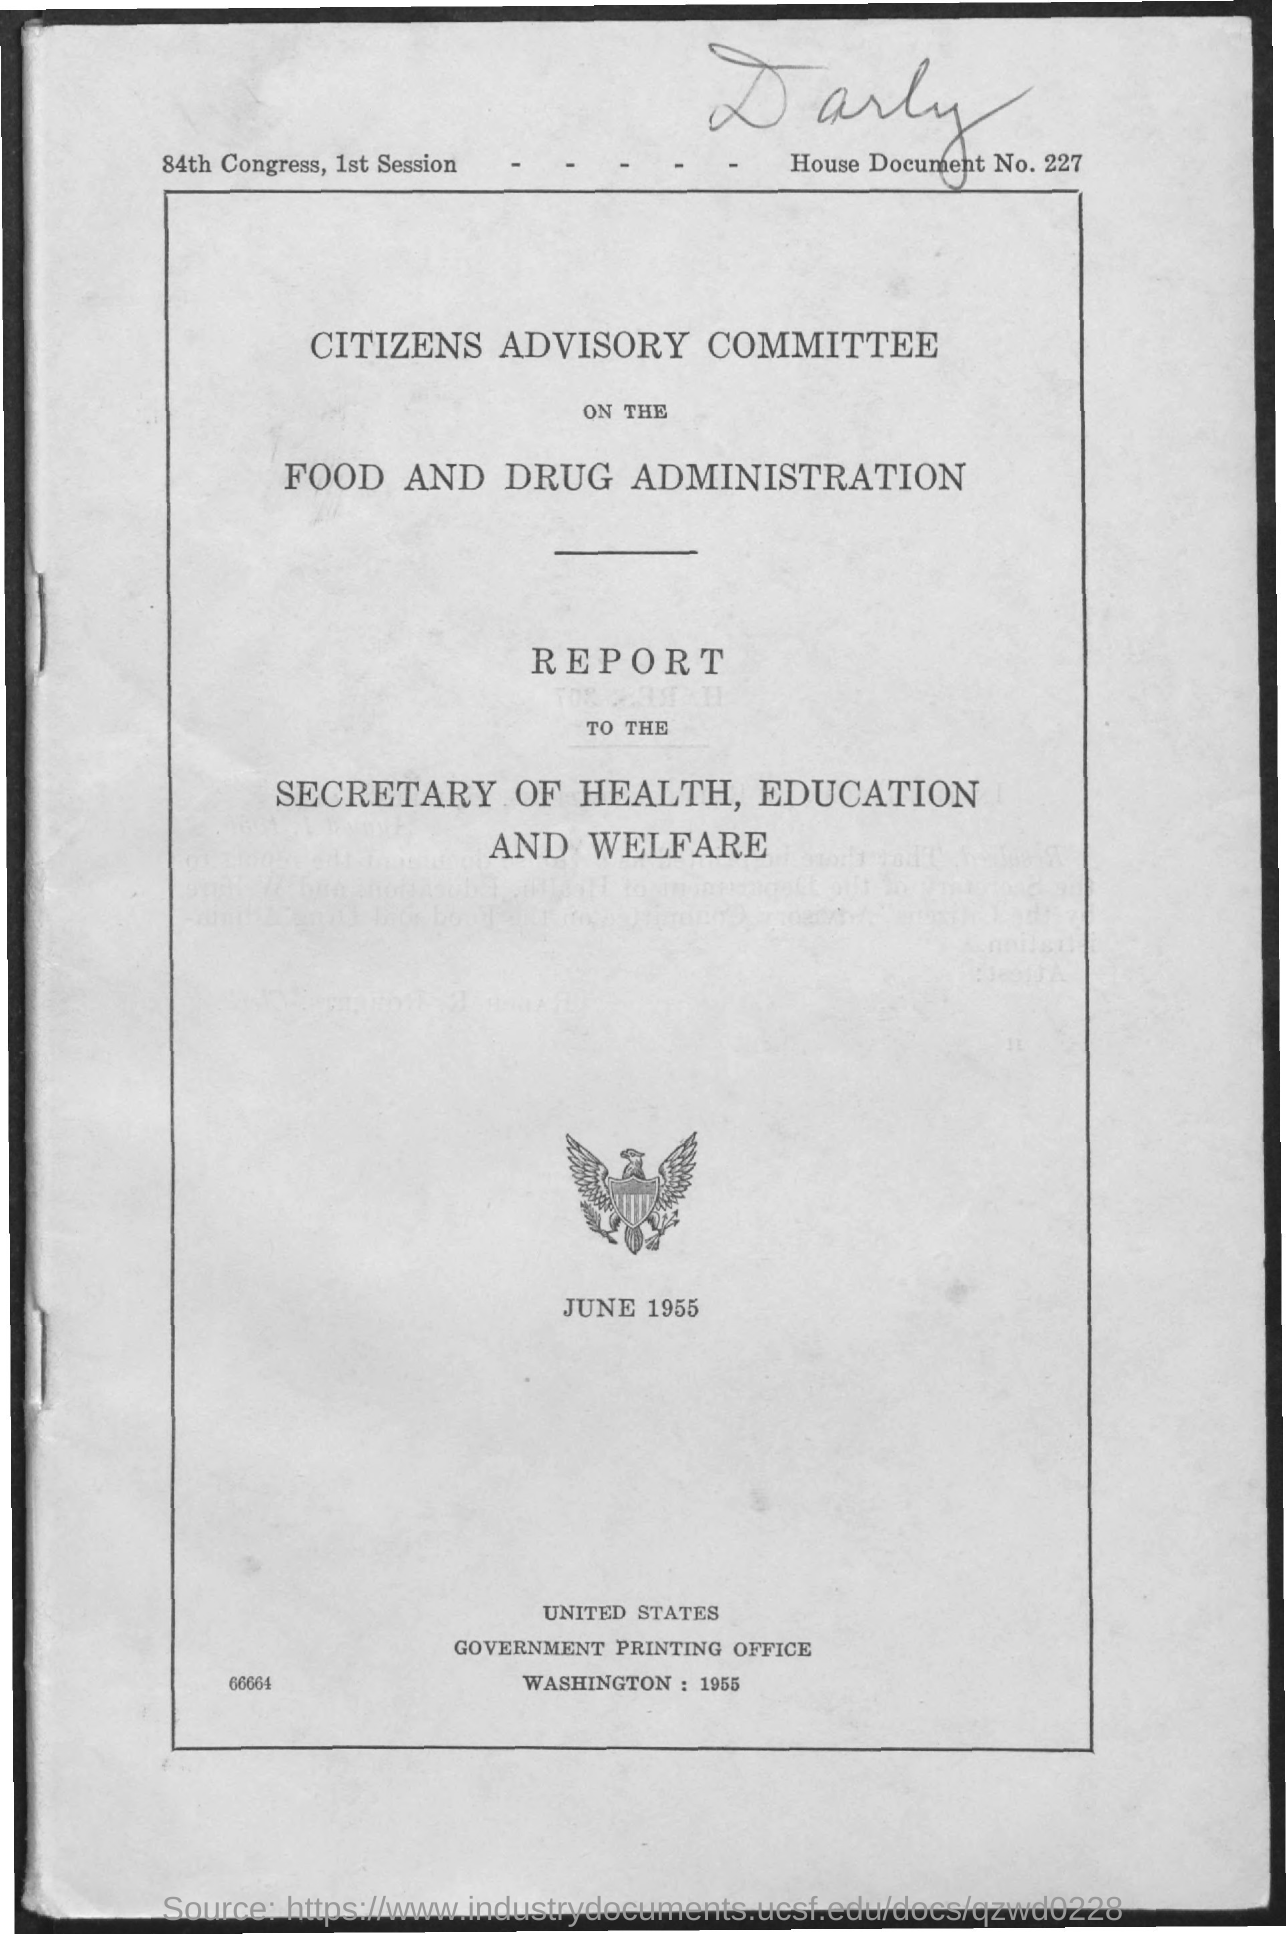What is the House Document No.?
Provide a succinct answer. 227. What is the date on the document?
Make the answer very short. June 1955. 